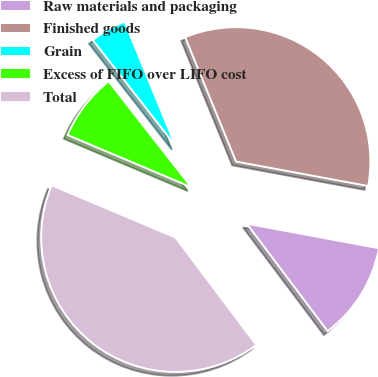Convert chart. <chart><loc_0><loc_0><loc_500><loc_500><pie_chart><fcel>Raw materials and packaging<fcel>Finished goods<fcel>Grain<fcel>Excess of FIFO over LIFO cost<fcel>Total<nl><fcel>11.82%<fcel>34.1%<fcel>4.37%<fcel>8.09%<fcel>41.61%<nl></chart> 